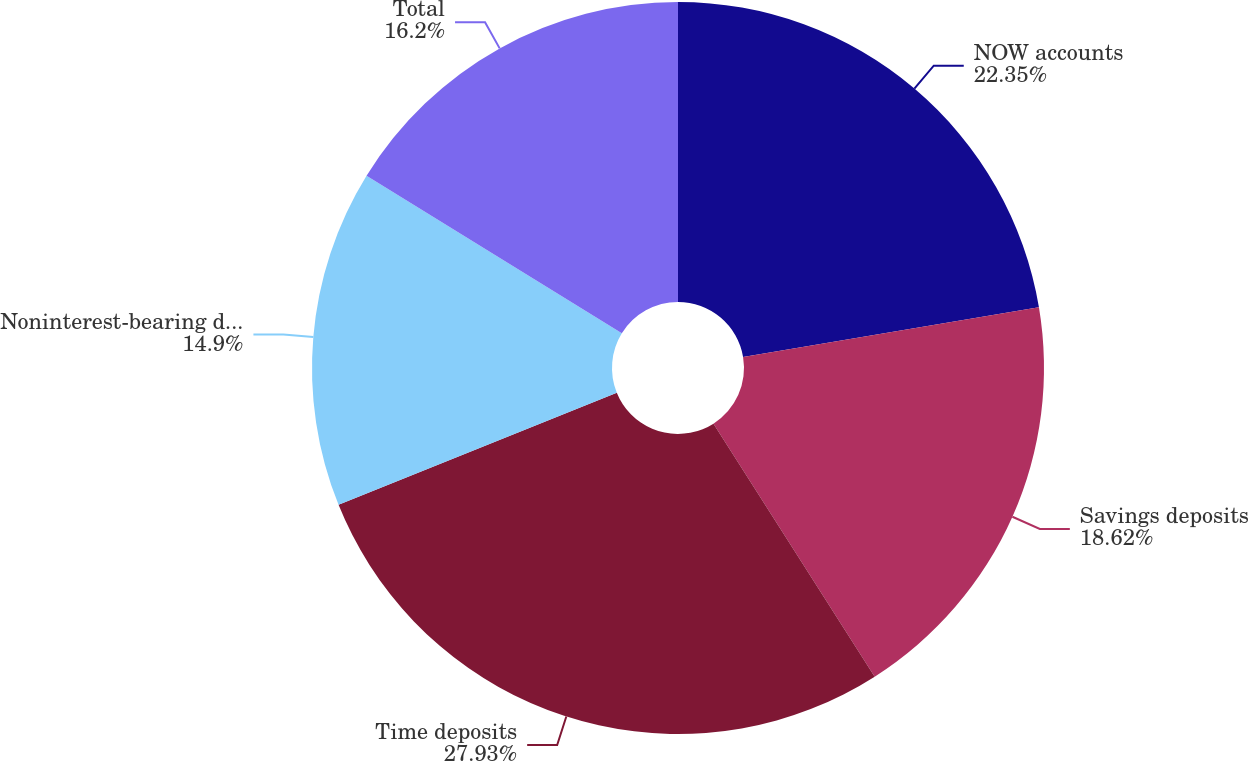<chart> <loc_0><loc_0><loc_500><loc_500><pie_chart><fcel>NOW accounts<fcel>Savings deposits<fcel>Time deposits<fcel>Noninterest-bearing deposits<fcel>Total<nl><fcel>22.35%<fcel>18.62%<fcel>27.93%<fcel>14.9%<fcel>16.2%<nl></chart> 